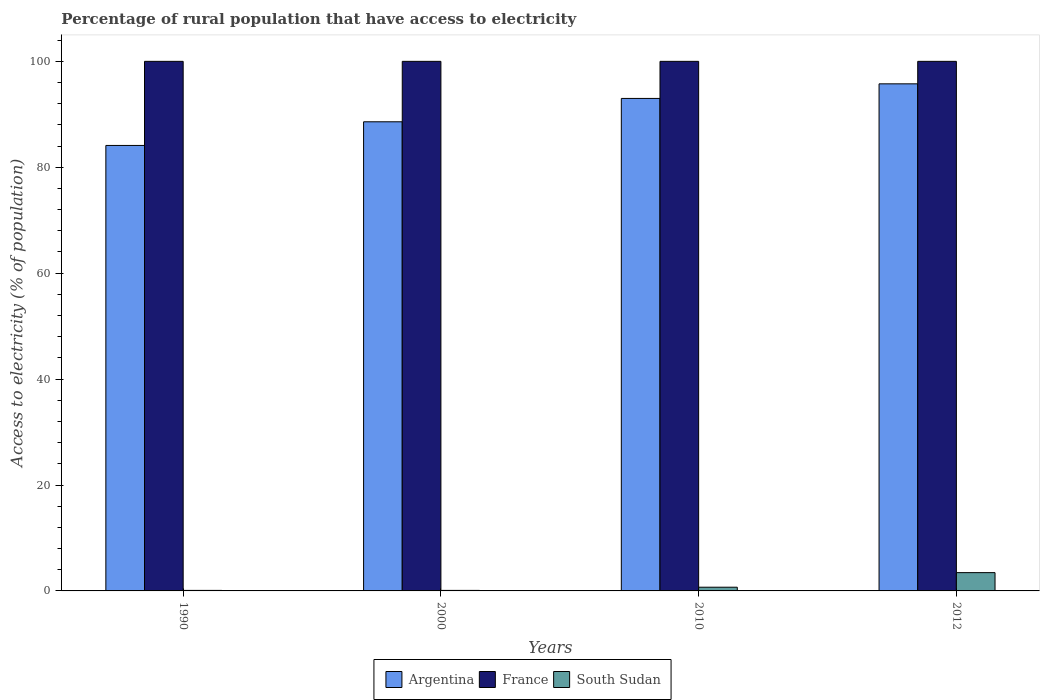How many groups of bars are there?
Offer a very short reply. 4. Are the number of bars per tick equal to the number of legend labels?
Give a very brief answer. Yes. How many bars are there on the 2nd tick from the left?
Your response must be concise. 3. In how many cases, is the number of bars for a given year not equal to the number of legend labels?
Make the answer very short. 0. What is the percentage of rural population that have access to electricity in Argentina in 2010?
Give a very brief answer. 93. Across all years, what is the maximum percentage of rural population that have access to electricity in France?
Give a very brief answer. 100. Across all years, what is the minimum percentage of rural population that have access to electricity in Argentina?
Keep it short and to the point. 84.12. What is the total percentage of rural population that have access to electricity in South Sudan in the graph?
Provide a short and direct response. 4.35. What is the difference between the percentage of rural population that have access to electricity in Argentina in 2012 and the percentage of rural population that have access to electricity in South Sudan in 1990?
Provide a short and direct response. 95.65. What is the average percentage of rural population that have access to electricity in South Sudan per year?
Your answer should be compact. 1.09. In the year 2010, what is the difference between the percentage of rural population that have access to electricity in South Sudan and percentage of rural population that have access to electricity in Argentina?
Provide a succinct answer. -92.3. In how many years, is the percentage of rural population that have access to electricity in South Sudan greater than 36 %?
Offer a very short reply. 0. What is the ratio of the percentage of rural population that have access to electricity in South Sudan in 1990 to that in 2012?
Provide a short and direct response. 0.03. Is the percentage of rural population that have access to electricity in France in 2010 less than that in 2012?
Provide a short and direct response. No. What is the difference between the highest and the second highest percentage of rural population that have access to electricity in France?
Offer a terse response. 0. What does the 1st bar from the right in 2012 represents?
Make the answer very short. South Sudan. Is it the case that in every year, the sum of the percentage of rural population that have access to electricity in South Sudan and percentage of rural population that have access to electricity in Argentina is greater than the percentage of rural population that have access to electricity in France?
Provide a succinct answer. No. How many years are there in the graph?
Offer a terse response. 4. How many legend labels are there?
Offer a terse response. 3. How are the legend labels stacked?
Your response must be concise. Horizontal. What is the title of the graph?
Offer a very short reply. Percentage of rural population that have access to electricity. Does "Pakistan" appear as one of the legend labels in the graph?
Offer a terse response. No. What is the label or title of the X-axis?
Keep it short and to the point. Years. What is the label or title of the Y-axis?
Provide a succinct answer. Access to electricity (% of population). What is the Access to electricity (% of population) of Argentina in 1990?
Your answer should be compact. 84.12. What is the Access to electricity (% of population) in South Sudan in 1990?
Ensure brevity in your answer.  0.1. What is the Access to electricity (% of population) of Argentina in 2000?
Your answer should be very brief. 88.59. What is the Access to electricity (% of population) of France in 2000?
Your response must be concise. 100. What is the Access to electricity (% of population) of South Sudan in 2000?
Keep it short and to the point. 0.1. What is the Access to electricity (% of population) of Argentina in 2010?
Keep it short and to the point. 93. What is the Access to electricity (% of population) in France in 2010?
Provide a short and direct response. 100. What is the Access to electricity (% of population) in South Sudan in 2010?
Your answer should be compact. 0.7. What is the Access to electricity (% of population) in Argentina in 2012?
Make the answer very short. 95.75. What is the Access to electricity (% of population) in France in 2012?
Provide a succinct answer. 100. What is the Access to electricity (% of population) in South Sudan in 2012?
Ensure brevity in your answer.  3.45. Across all years, what is the maximum Access to electricity (% of population) of Argentina?
Give a very brief answer. 95.75. Across all years, what is the maximum Access to electricity (% of population) of France?
Provide a succinct answer. 100. Across all years, what is the maximum Access to electricity (% of population) of South Sudan?
Provide a short and direct response. 3.45. Across all years, what is the minimum Access to electricity (% of population) in Argentina?
Provide a succinct answer. 84.12. Across all years, what is the minimum Access to electricity (% of population) in South Sudan?
Ensure brevity in your answer.  0.1. What is the total Access to electricity (% of population) of Argentina in the graph?
Offer a very short reply. 361.46. What is the total Access to electricity (% of population) of France in the graph?
Give a very brief answer. 400. What is the total Access to electricity (% of population) in South Sudan in the graph?
Offer a very short reply. 4.35. What is the difference between the Access to electricity (% of population) in Argentina in 1990 and that in 2000?
Offer a terse response. -4.47. What is the difference between the Access to electricity (% of population) in France in 1990 and that in 2000?
Keep it short and to the point. 0. What is the difference between the Access to electricity (% of population) of Argentina in 1990 and that in 2010?
Your answer should be compact. -8.88. What is the difference between the Access to electricity (% of population) of France in 1990 and that in 2010?
Make the answer very short. 0. What is the difference between the Access to electricity (% of population) of South Sudan in 1990 and that in 2010?
Offer a terse response. -0.6. What is the difference between the Access to electricity (% of population) in Argentina in 1990 and that in 2012?
Make the answer very short. -11.63. What is the difference between the Access to electricity (% of population) of France in 1990 and that in 2012?
Keep it short and to the point. 0. What is the difference between the Access to electricity (% of population) of South Sudan in 1990 and that in 2012?
Keep it short and to the point. -3.35. What is the difference between the Access to electricity (% of population) of Argentina in 2000 and that in 2010?
Make the answer very short. -4.41. What is the difference between the Access to electricity (% of population) in France in 2000 and that in 2010?
Ensure brevity in your answer.  0. What is the difference between the Access to electricity (% of population) in Argentina in 2000 and that in 2012?
Provide a succinct answer. -7.17. What is the difference between the Access to electricity (% of population) of France in 2000 and that in 2012?
Give a very brief answer. 0. What is the difference between the Access to electricity (% of population) in South Sudan in 2000 and that in 2012?
Your answer should be compact. -3.35. What is the difference between the Access to electricity (% of population) of Argentina in 2010 and that in 2012?
Keep it short and to the point. -2.75. What is the difference between the Access to electricity (% of population) in South Sudan in 2010 and that in 2012?
Ensure brevity in your answer.  -2.75. What is the difference between the Access to electricity (% of population) in Argentina in 1990 and the Access to electricity (% of population) in France in 2000?
Give a very brief answer. -15.88. What is the difference between the Access to electricity (% of population) of Argentina in 1990 and the Access to electricity (% of population) of South Sudan in 2000?
Give a very brief answer. 84.02. What is the difference between the Access to electricity (% of population) in France in 1990 and the Access to electricity (% of population) in South Sudan in 2000?
Your answer should be compact. 99.9. What is the difference between the Access to electricity (% of population) in Argentina in 1990 and the Access to electricity (% of population) in France in 2010?
Your answer should be very brief. -15.88. What is the difference between the Access to electricity (% of population) of Argentina in 1990 and the Access to electricity (% of population) of South Sudan in 2010?
Keep it short and to the point. 83.42. What is the difference between the Access to electricity (% of population) in France in 1990 and the Access to electricity (% of population) in South Sudan in 2010?
Give a very brief answer. 99.3. What is the difference between the Access to electricity (% of population) in Argentina in 1990 and the Access to electricity (% of population) in France in 2012?
Offer a terse response. -15.88. What is the difference between the Access to electricity (% of population) in Argentina in 1990 and the Access to electricity (% of population) in South Sudan in 2012?
Give a very brief answer. 80.67. What is the difference between the Access to electricity (% of population) of France in 1990 and the Access to electricity (% of population) of South Sudan in 2012?
Ensure brevity in your answer.  96.55. What is the difference between the Access to electricity (% of population) of Argentina in 2000 and the Access to electricity (% of population) of France in 2010?
Offer a terse response. -11.41. What is the difference between the Access to electricity (% of population) of Argentina in 2000 and the Access to electricity (% of population) of South Sudan in 2010?
Your answer should be compact. 87.89. What is the difference between the Access to electricity (% of population) in France in 2000 and the Access to electricity (% of population) in South Sudan in 2010?
Keep it short and to the point. 99.3. What is the difference between the Access to electricity (% of population) in Argentina in 2000 and the Access to electricity (% of population) in France in 2012?
Ensure brevity in your answer.  -11.41. What is the difference between the Access to electricity (% of population) of Argentina in 2000 and the Access to electricity (% of population) of South Sudan in 2012?
Give a very brief answer. 85.13. What is the difference between the Access to electricity (% of population) of France in 2000 and the Access to electricity (% of population) of South Sudan in 2012?
Your answer should be very brief. 96.55. What is the difference between the Access to electricity (% of population) of Argentina in 2010 and the Access to electricity (% of population) of France in 2012?
Make the answer very short. -7. What is the difference between the Access to electricity (% of population) in Argentina in 2010 and the Access to electricity (% of population) in South Sudan in 2012?
Provide a succinct answer. 89.55. What is the difference between the Access to electricity (% of population) in France in 2010 and the Access to electricity (% of population) in South Sudan in 2012?
Offer a very short reply. 96.55. What is the average Access to electricity (% of population) in Argentina per year?
Give a very brief answer. 90.37. What is the average Access to electricity (% of population) of South Sudan per year?
Offer a very short reply. 1.09. In the year 1990, what is the difference between the Access to electricity (% of population) of Argentina and Access to electricity (% of population) of France?
Provide a short and direct response. -15.88. In the year 1990, what is the difference between the Access to electricity (% of population) in Argentina and Access to electricity (% of population) in South Sudan?
Your response must be concise. 84.02. In the year 1990, what is the difference between the Access to electricity (% of population) in France and Access to electricity (% of population) in South Sudan?
Your answer should be very brief. 99.9. In the year 2000, what is the difference between the Access to electricity (% of population) of Argentina and Access to electricity (% of population) of France?
Provide a succinct answer. -11.41. In the year 2000, what is the difference between the Access to electricity (% of population) of Argentina and Access to electricity (% of population) of South Sudan?
Your answer should be compact. 88.49. In the year 2000, what is the difference between the Access to electricity (% of population) of France and Access to electricity (% of population) of South Sudan?
Make the answer very short. 99.9. In the year 2010, what is the difference between the Access to electricity (% of population) in Argentina and Access to electricity (% of population) in France?
Give a very brief answer. -7. In the year 2010, what is the difference between the Access to electricity (% of population) of Argentina and Access to electricity (% of population) of South Sudan?
Offer a very short reply. 92.3. In the year 2010, what is the difference between the Access to electricity (% of population) in France and Access to electricity (% of population) in South Sudan?
Provide a succinct answer. 99.3. In the year 2012, what is the difference between the Access to electricity (% of population) of Argentina and Access to electricity (% of population) of France?
Keep it short and to the point. -4.25. In the year 2012, what is the difference between the Access to electricity (% of population) of Argentina and Access to electricity (% of population) of South Sudan?
Offer a terse response. 92.3. In the year 2012, what is the difference between the Access to electricity (% of population) in France and Access to electricity (% of population) in South Sudan?
Your response must be concise. 96.55. What is the ratio of the Access to electricity (% of population) in Argentina in 1990 to that in 2000?
Ensure brevity in your answer.  0.95. What is the ratio of the Access to electricity (% of population) of France in 1990 to that in 2000?
Provide a succinct answer. 1. What is the ratio of the Access to electricity (% of population) in Argentina in 1990 to that in 2010?
Keep it short and to the point. 0.9. What is the ratio of the Access to electricity (% of population) in South Sudan in 1990 to that in 2010?
Keep it short and to the point. 0.14. What is the ratio of the Access to electricity (% of population) in Argentina in 1990 to that in 2012?
Make the answer very short. 0.88. What is the ratio of the Access to electricity (% of population) in France in 1990 to that in 2012?
Your response must be concise. 1. What is the ratio of the Access to electricity (% of population) in South Sudan in 1990 to that in 2012?
Give a very brief answer. 0.03. What is the ratio of the Access to electricity (% of population) of Argentina in 2000 to that in 2010?
Your response must be concise. 0.95. What is the ratio of the Access to electricity (% of population) in France in 2000 to that in 2010?
Your response must be concise. 1. What is the ratio of the Access to electricity (% of population) of South Sudan in 2000 to that in 2010?
Give a very brief answer. 0.14. What is the ratio of the Access to electricity (% of population) in Argentina in 2000 to that in 2012?
Your answer should be very brief. 0.93. What is the ratio of the Access to electricity (% of population) of France in 2000 to that in 2012?
Your answer should be compact. 1. What is the ratio of the Access to electricity (% of population) in South Sudan in 2000 to that in 2012?
Your answer should be compact. 0.03. What is the ratio of the Access to electricity (% of population) of Argentina in 2010 to that in 2012?
Ensure brevity in your answer.  0.97. What is the ratio of the Access to electricity (% of population) of South Sudan in 2010 to that in 2012?
Your answer should be compact. 0.2. What is the difference between the highest and the second highest Access to electricity (% of population) of Argentina?
Your answer should be compact. 2.75. What is the difference between the highest and the second highest Access to electricity (% of population) of South Sudan?
Offer a terse response. 2.75. What is the difference between the highest and the lowest Access to electricity (% of population) in Argentina?
Offer a very short reply. 11.63. What is the difference between the highest and the lowest Access to electricity (% of population) in France?
Provide a short and direct response. 0. What is the difference between the highest and the lowest Access to electricity (% of population) of South Sudan?
Ensure brevity in your answer.  3.35. 